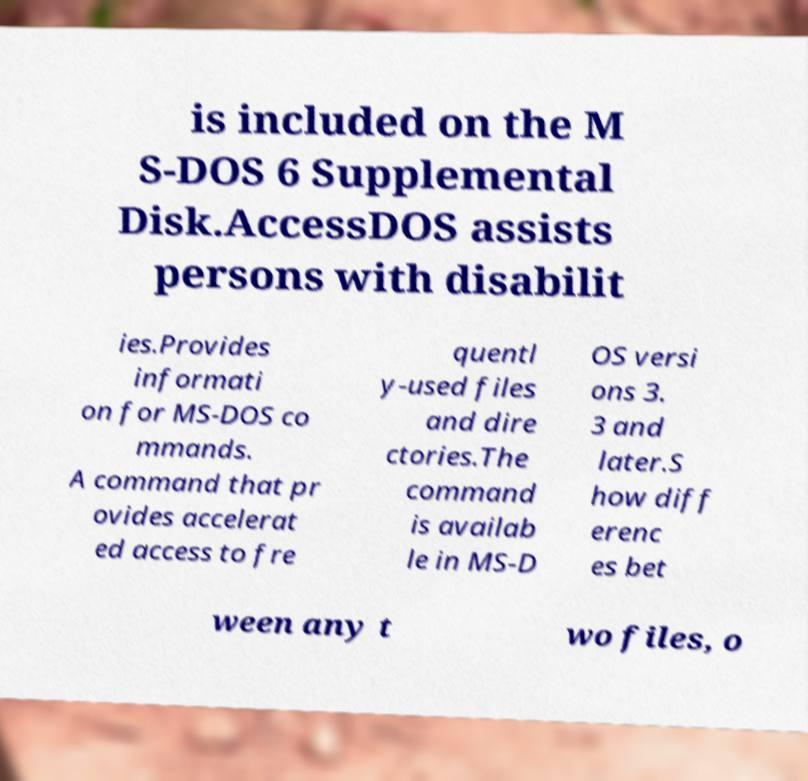There's text embedded in this image that I need extracted. Can you transcribe it verbatim? is included on the M S-DOS 6 Supplemental Disk.AccessDOS assists persons with disabilit ies.Provides informati on for MS-DOS co mmands. A command that pr ovides accelerat ed access to fre quentl y-used files and dire ctories.The command is availab le in MS-D OS versi ons 3. 3 and later.S how diff erenc es bet ween any t wo files, o 